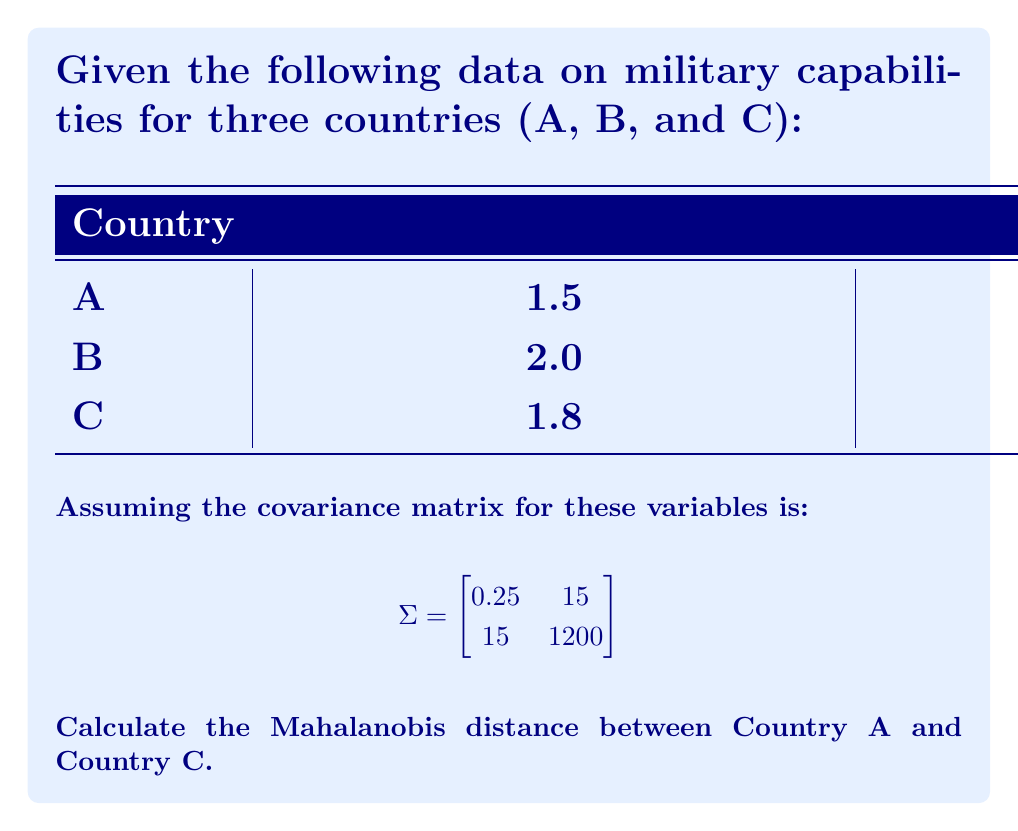Teach me how to tackle this problem. To calculate the Mahalanobis distance between Country A and Country C, we'll follow these steps:

1) The Mahalanobis distance formula is:

   $$d = \sqrt{(x_1 - x_2)^T \Sigma^{-1} (x_1 - x_2)}$$

   where $x_1$ and $x_2$ are the vectors of observations for the two countries, and $\Sigma^{-1}$ is the inverse of the covariance matrix.

2) First, let's define our vectors:
   
   $x_1 = \begin{bmatrix} 1.5 \\ 50 \end{bmatrix}$ (Country A)
   
   $x_2 = \begin{bmatrix} 1.8 \\ 60 \end{bmatrix}$ (Country C)

3) Calculate $(x_1 - x_2)$:

   $$x_1 - x_2 = \begin{bmatrix} 1.5 - 1.8 \\ 50 - 60 \end{bmatrix} = \begin{bmatrix} -0.3 \\ -10 \end{bmatrix}$$

4) Now we need to find $\Sigma^{-1}$. The inverse of a 2x2 matrix $\begin{bmatrix} a & b \\ c & d \end{bmatrix}$ is:

   $$\frac{1}{ad-bc} \begin{bmatrix} d & -b \\ -c & a \end{bmatrix}$$

   So, 
   $$\Sigma^{-1} = \frac{1}{0.25 * 1200 - 15 * 15} \begin{bmatrix} 1200 & -15 \\ -15 & 0.25 \end{bmatrix}$$
   
   $$= \frac{1}{300 - 225} \begin{bmatrix} 1200 & -15 \\ -15 & 0.25 \end{bmatrix} = \frac{1}{75} \begin{bmatrix} 1200 & -15 \\ -15 & 0.25 \end{bmatrix}$$

5) Now we can calculate $(x_1 - x_2)^T \Sigma^{-1} (x_1 - x_2)$:

   $$\begin{bmatrix} -0.3 & -10 \end{bmatrix} \frac{1}{75} \begin{bmatrix} 1200 & -15 \\ -15 & 0.25 \end{bmatrix} \begin{bmatrix} -0.3 \\ -10 \end{bmatrix}$$

6) Multiplying these matrices:

   $$\frac{1}{75} \begin{bmatrix} -0.3 & -10 \end{bmatrix} \begin{bmatrix} -360 \\ -2.5 \end{bmatrix} = \frac{1}{75} (108 + 25) = \frac{133}{75} = 1.7733$$

7) Finally, we take the square root to get the Mahalanobis distance:

   $$d = \sqrt{1.7733} = 1.3317$$
Answer: $1.3317$ 